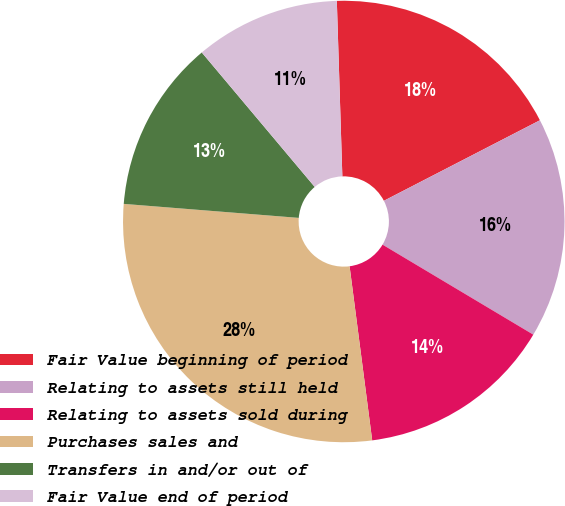<chart> <loc_0><loc_0><loc_500><loc_500><pie_chart><fcel>Fair Value beginning of period<fcel>Relating to assets still held<fcel>Relating to assets sold during<fcel>Purchases sales and<fcel>Transfers in and/or out of<fcel>Fair Value end of period<nl><fcel>17.92%<fcel>16.15%<fcel>14.38%<fcel>28.33%<fcel>12.61%<fcel>10.62%<nl></chart> 